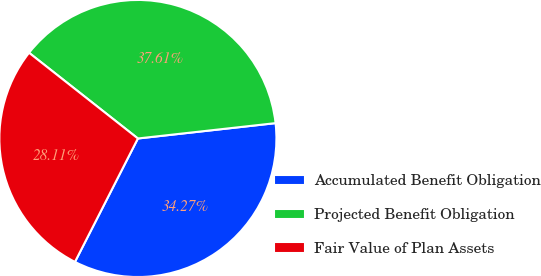Convert chart. <chart><loc_0><loc_0><loc_500><loc_500><pie_chart><fcel>Accumulated Benefit Obligation<fcel>Projected Benefit Obligation<fcel>Fair Value of Plan Assets<nl><fcel>34.27%<fcel>37.61%<fcel>28.11%<nl></chart> 